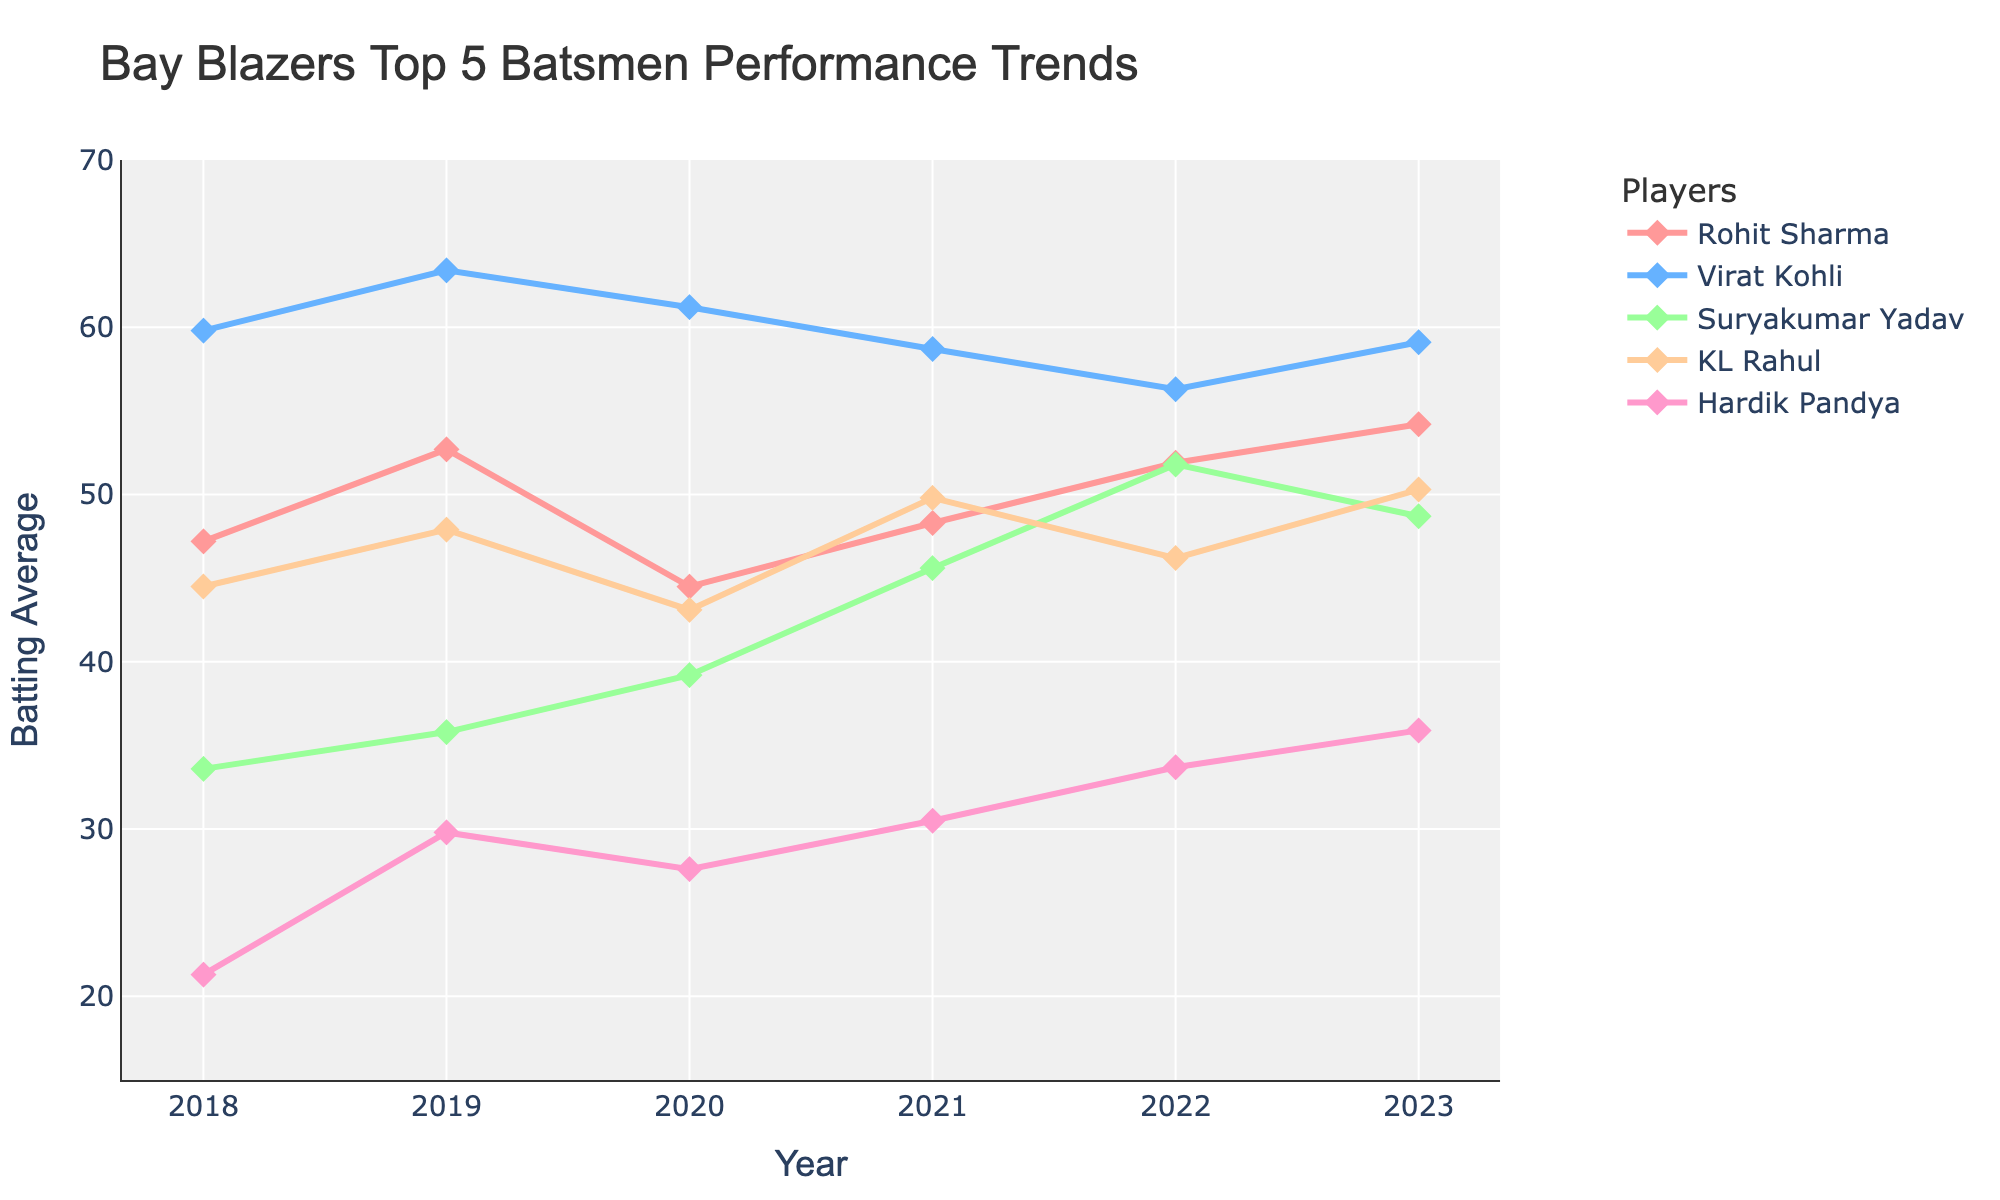what was the batting average of Suryakumar Yadav and Hardik Pandya in 2020? Refer to the values corresponding to the year 2020 for both players on the chart. The averages are 39.2 for Suryakumar Yadav and 27.6 for Hardik Pandya.
Answer: 39.2, 27.6 which player had the highest average in 2021? Look at the data points for the year 2021 and identify the player with the highest value. Virat Kohli had the highest average with 58.7.
Answer: Virat Kohli compare the batting averages of Rohit Sharma and KL Rahul in 2023. Who had a higher average? Check the values corresponding to the year 2023 for both players. Rohit Sharma had an average of 54.2 while KL Rahul had an average of 50.3. Thus, Rohit Sharma had a higher average.
Answer: Rohit Sharma Did any player's batting average continually increase from 2018 to 2023? Evaluate the chart to see if any player's line consistently slopes upward from 2018 to 2023. Suryakumar Yadav's average continually increased from 33.6 in 2018 to 48.7 in 2023.
Answer: Suryakumar Yadav by how much did Hardik Pandya's batting average increase from 2019 to 2023? Take the value of Hardik Pandya's batting average in 2023 (35.9) and subtract his average in 2019 (29.8). The increase is 35.9 - 29.8 = 6.1.
Answer: 6.1 who had the lowest batting average in 2018 and what was it? Look at the values for the year 2018 and identify the player with the lowest average. Hardik Pandya had the lowest average with 21.3.
Answer: Hardik Pandya, 21.3 which player showed the least variation in batting average from 2018 to 2023? Compare the range of values for each player over the period 2018-2023 and identify the one with the smallest range. Virat Kohli's range is 63.4 - 56.3 = 7.1, which is the smallest.
Answer: Virat Kohli what was the trend in KL Rahul's batting average from 2018 to 2023? Observe the trajectory of KL Rahul's line from 2018 to 2023. His average generally increased over time, peaking in 2023 at 50.3.
Answer: Increasing what is the average batting average of Rohit Sharma from 2018 to 2023? Sum up Rohit Sharma's averages for each year (47.2 + 52.7 + 44.5 + 48.3 + 51.9 + 54.2 = 298.8) and divide by the number of years (6). The average is 298.8 / 6 = 49.8.
Answer: 49.8 